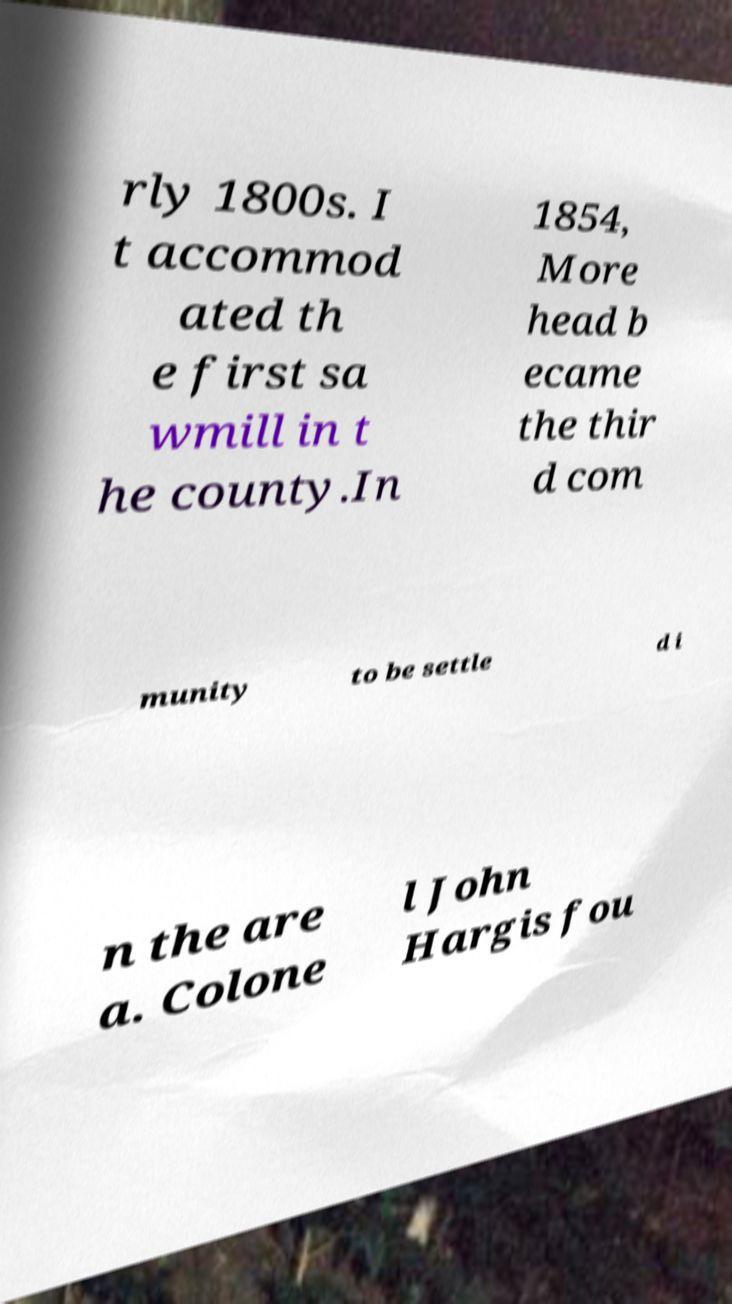Could you extract and type out the text from this image? rly 1800s. I t accommod ated th e first sa wmill in t he county.In 1854, More head b ecame the thir d com munity to be settle d i n the are a. Colone l John Hargis fou 